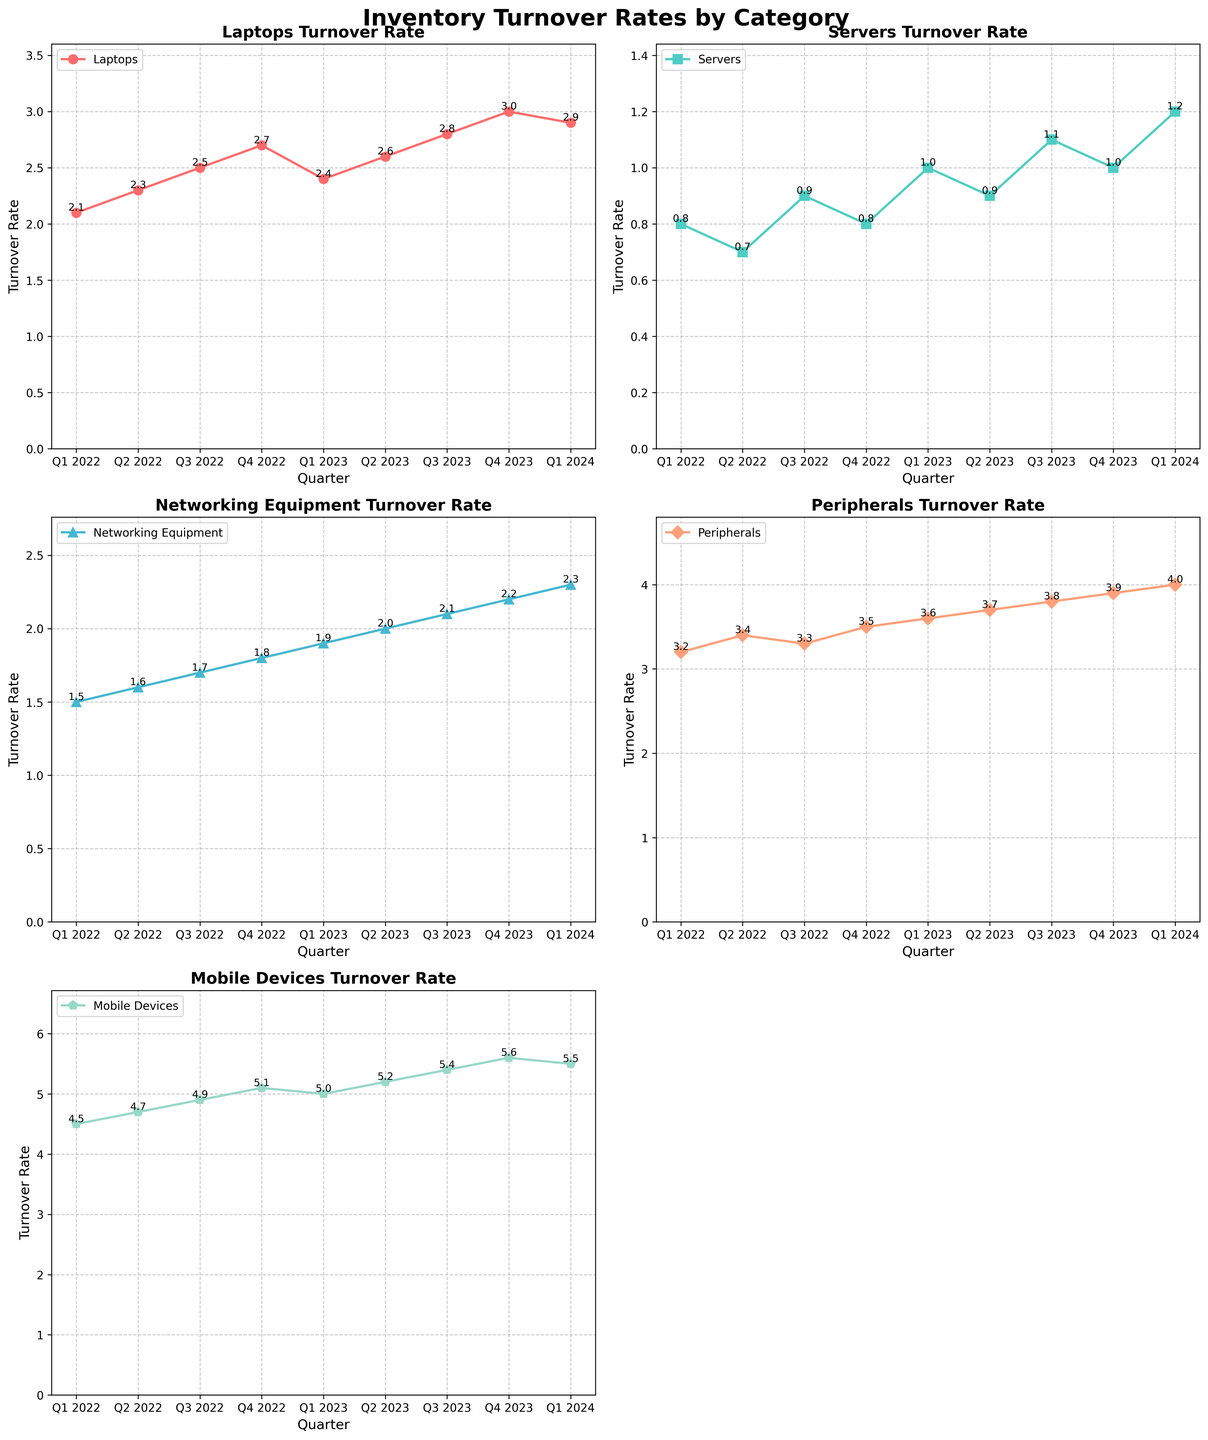Which category has the highest turnover rate in Q3 2023? Check the subplot for Q3 2023 and compare the turnover rates of all categories. The category with the highest turnover rate in Q3 2023 is Mobile Devices with a rate of 5.4.
Answer: Mobile Devices Which category has the lowest turnover rate in Q4 2022? Observe the subplot for Q4 2022 and identify the category with the lowest turnover rate. Servers have the lowest turnover rate of 0.8 in Q4 2022.
Answer: Servers What is the difference in turnover rate between Laptops and Servers in Q1 2024? Check the respective subplots for Q1 2024 and subtract the turnover rate of Servers (1.2) from the turnover rate of Laptops (2.9). The difference is 2.9 - 1.2 = 1.7.
Answer: 1.7 How much did the turnover rate for Peripherals increase from Q1 2022 to Q4 2023? Note the turnover rates for Peripherals in Q1 2022 (3.2) and Q4 2023 (3.9), then subtract the former from the latter. The increase is 3.9 - 3.2 = 0.7.
Answer: 0.7 Did any category show a consistent increase in turnover rate over all quarters? Analyze each subplot and look for a category whose turnover rate rises every consecutive quarter. Mobile Devices steadily increase each quarter from Q1 2022 to Q1 2024.
Answer: Mobile Devices Between Q1 2023 and Q3 2023, which category showed the largest increase in turnover rate? Compare the turnover rates for Q1 2023 and Q3 2023 for each category and calculate the differences. Networking Equipment increased from 1.9 to 2.1, showing the largest increase of 0.2.
Answer: Networking Equipment What is the average turnover rate of Networking Equipment throughout all quarters? Sum the turnover rates for Networking Equipment across all quarters and divide by the number of quarters (9). The sum is 1.5 + 1.6 + 1.7 + 1.8 + 1.9 + 2.0 + 2.1 + 2.2 + 2.3 = 17.1. The average is 17.1 / 9 = 1.9.
Answer: 1.9 Which category has the greatest variability in turnover rates over the recorded quarters? Observe the variation in turnover rates for each category, considering the differences between their maximum and minimum values. Mobile Devices vary from 4.5 to 5.6, a range of 1.1, which is the greatest among all categories.
Answer: Mobile Devices 